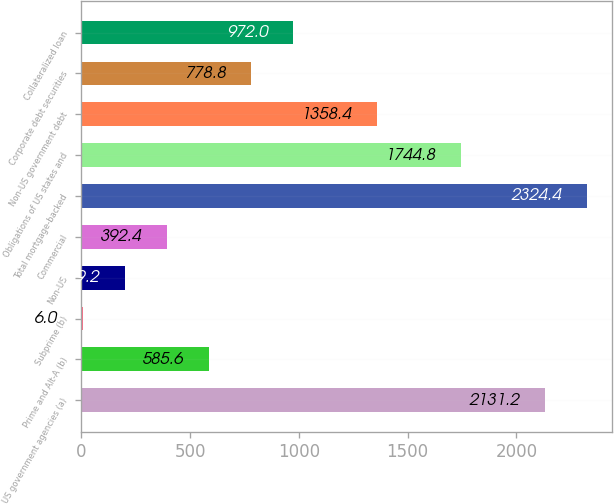Convert chart. <chart><loc_0><loc_0><loc_500><loc_500><bar_chart><fcel>US government agencies (a)<fcel>Prime and Alt-A (b)<fcel>Subprime (b)<fcel>Non-US<fcel>Commercial<fcel>Total mortgage-backed<fcel>Obligations of US states and<fcel>Non-US government debt<fcel>Corporate debt securities<fcel>Collateralized loan<nl><fcel>2131.2<fcel>585.6<fcel>6<fcel>199.2<fcel>392.4<fcel>2324.4<fcel>1744.8<fcel>1358.4<fcel>778.8<fcel>972<nl></chart> 